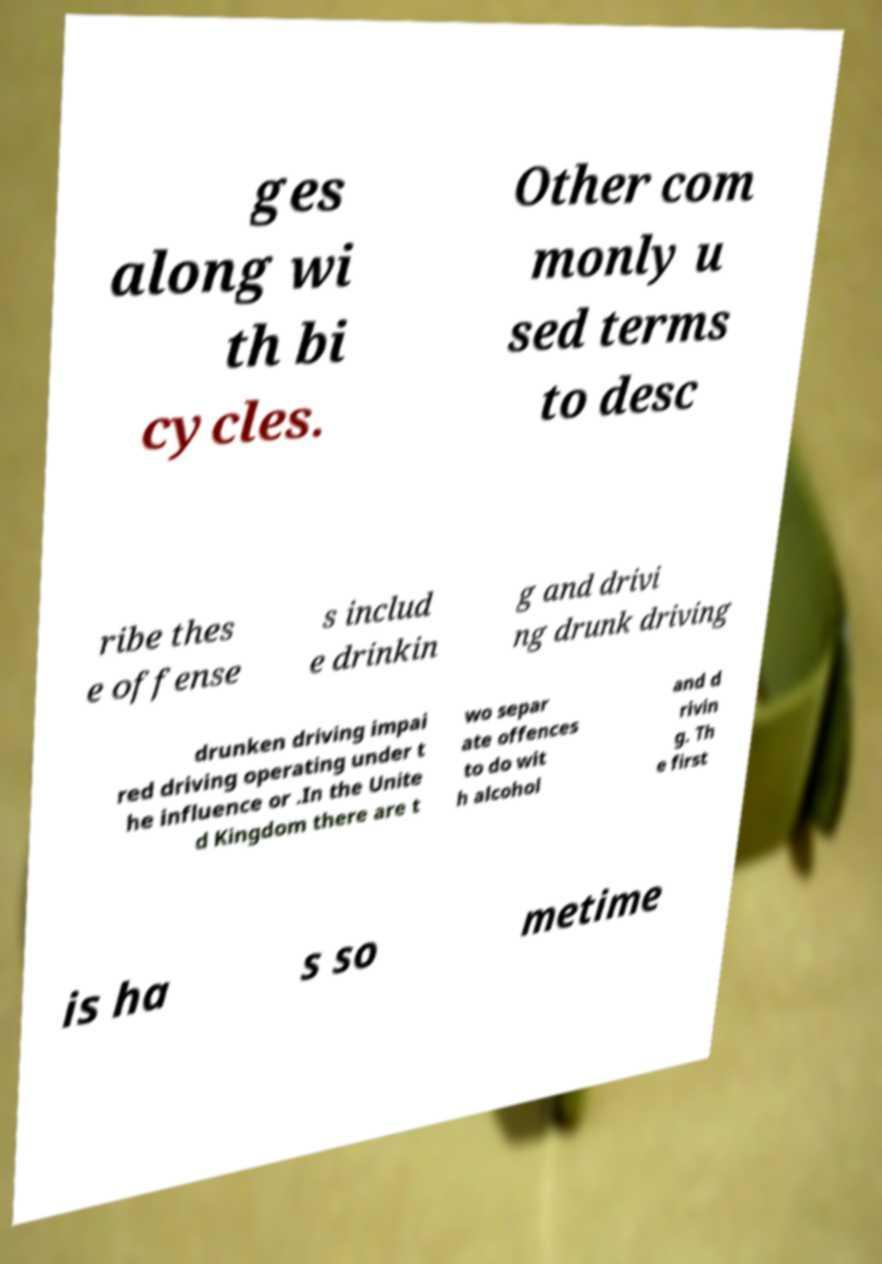Please identify and transcribe the text found in this image. ges along wi th bi cycles. Other com monly u sed terms to desc ribe thes e offense s includ e drinkin g and drivi ng drunk driving drunken driving impai red driving operating under t he influence or .In the Unite d Kingdom there are t wo separ ate offences to do wit h alcohol and d rivin g. Th e first is ha s so metime 